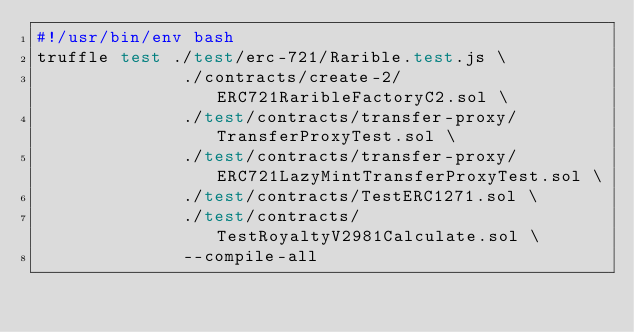<code> <loc_0><loc_0><loc_500><loc_500><_Bash_>#!/usr/bin/env bash
truffle test ./test/erc-721/Rarible.test.js \
              ./contracts/create-2/ERC721RaribleFactoryC2.sol \
              ./test/contracts/transfer-proxy/TransferProxyTest.sol \
              ./test/contracts/transfer-proxy/ERC721LazyMintTransferProxyTest.sol \
              ./test/contracts/TestERC1271.sol \
              ./test/contracts/TestRoyaltyV2981Calculate.sol \
              --compile-all
              </code> 